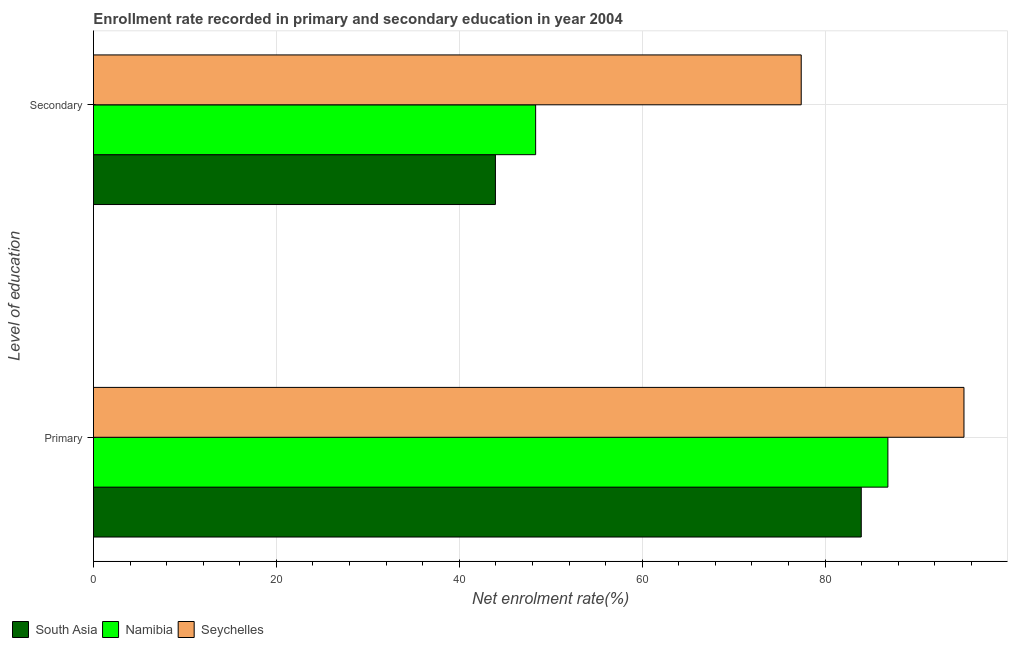How many different coloured bars are there?
Make the answer very short. 3. Are the number of bars on each tick of the Y-axis equal?
Offer a terse response. Yes. What is the label of the 2nd group of bars from the top?
Provide a succinct answer. Primary. What is the enrollment rate in secondary education in Namibia?
Provide a short and direct response. 48.35. Across all countries, what is the maximum enrollment rate in secondary education?
Ensure brevity in your answer.  77.39. Across all countries, what is the minimum enrollment rate in secondary education?
Give a very brief answer. 43.95. In which country was the enrollment rate in primary education maximum?
Give a very brief answer. Seychelles. In which country was the enrollment rate in secondary education minimum?
Provide a succinct answer. South Asia. What is the total enrollment rate in secondary education in the graph?
Provide a succinct answer. 169.69. What is the difference between the enrollment rate in secondary education in Namibia and that in South Asia?
Ensure brevity in your answer.  4.4. What is the difference between the enrollment rate in secondary education in Seychelles and the enrollment rate in primary education in South Asia?
Provide a short and direct response. -6.57. What is the average enrollment rate in primary education per country?
Your response must be concise. 88.67. What is the difference between the enrollment rate in secondary education and enrollment rate in primary education in Seychelles?
Make the answer very short. -17.8. What is the ratio of the enrollment rate in secondary education in Namibia to that in South Asia?
Make the answer very short. 1.1. Is the enrollment rate in primary education in Namibia less than that in Seychelles?
Make the answer very short. Yes. In how many countries, is the enrollment rate in secondary education greater than the average enrollment rate in secondary education taken over all countries?
Your answer should be compact. 1. What does the 3rd bar from the top in Secondary represents?
Give a very brief answer. South Asia. How many bars are there?
Offer a very short reply. 6. Are the values on the major ticks of X-axis written in scientific E-notation?
Make the answer very short. No. How many legend labels are there?
Your answer should be compact. 3. What is the title of the graph?
Your answer should be compact. Enrollment rate recorded in primary and secondary education in year 2004. What is the label or title of the X-axis?
Your response must be concise. Net enrolment rate(%). What is the label or title of the Y-axis?
Provide a succinct answer. Level of education. What is the Net enrolment rate(%) in South Asia in Primary?
Offer a very short reply. 83.96. What is the Net enrolment rate(%) of Namibia in Primary?
Offer a very short reply. 86.87. What is the Net enrolment rate(%) in Seychelles in Primary?
Your response must be concise. 95.19. What is the Net enrolment rate(%) in South Asia in Secondary?
Keep it short and to the point. 43.95. What is the Net enrolment rate(%) in Namibia in Secondary?
Give a very brief answer. 48.35. What is the Net enrolment rate(%) in Seychelles in Secondary?
Keep it short and to the point. 77.39. Across all Level of education, what is the maximum Net enrolment rate(%) in South Asia?
Make the answer very short. 83.96. Across all Level of education, what is the maximum Net enrolment rate(%) in Namibia?
Make the answer very short. 86.87. Across all Level of education, what is the maximum Net enrolment rate(%) of Seychelles?
Make the answer very short. 95.19. Across all Level of education, what is the minimum Net enrolment rate(%) in South Asia?
Your answer should be very brief. 43.95. Across all Level of education, what is the minimum Net enrolment rate(%) in Namibia?
Your answer should be compact. 48.35. Across all Level of education, what is the minimum Net enrolment rate(%) of Seychelles?
Offer a terse response. 77.39. What is the total Net enrolment rate(%) of South Asia in the graph?
Offer a very short reply. 127.91. What is the total Net enrolment rate(%) in Namibia in the graph?
Your answer should be compact. 135.22. What is the total Net enrolment rate(%) in Seychelles in the graph?
Give a very brief answer. 172.58. What is the difference between the Net enrolment rate(%) in South Asia in Primary and that in Secondary?
Offer a terse response. 40.01. What is the difference between the Net enrolment rate(%) of Namibia in Primary and that in Secondary?
Give a very brief answer. 38.52. What is the difference between the Net enrolment rate(%) of Seychelles in Primary and that in Secondary?
Offer a very short reply. 17.8. What is the difference between the Net enrolment rate(%) in South Asia in Primary and the Net enrolment rate(%) in Namibia in Secondary?
Give a very brief answer. 35.61. What is the difference between the Net enrolment rate(%) in South Asia in Primary and the Net enrolment rate(%) in Seychelles in Secondary?
Your answer should be very brief. 6.57. What is the difference between the Net enrolment rate(%) in Namibia in Primary and the Net enrolment rate(%) in Seychelles in Secondary?
Provide a short and direct response. 9.48. What is the average Net enrolment rate(%) in South Asia per Level of education?
Provide a short and direct response. 63.95. What is the average Net enrolment rate(%) of Namibia per Level of education?
Your answer should be very brief. 67.61. What is the average Net enrolment rate(%) in Seychelles per Level of education?
Offer a terse response. 86.29. What is the difference between the Net enrolment rate(%) in South Asia and Net enrolment rate(%) in Namibia in Primary?
Keep it short and to the point. -2.91. What is the difference between the Net enrolment rate(%) in South Asia and Net enrolment rate(%) in Seychelles in Primary?
Give a very brief answer. -11.23. What is the difference between the Net enrolment rate(%) of Namibia and Net enrolment rate(%) of Seychelles in Primary?
Ensure brevity in your answer.  -8.32. What is the difference between the Net enrolment rate(%) of South Asia and Net enrolment rate(%) of Namibia in Secondary?
Offer a terse response. -4.4. What is the difference between the Net enrolment rate(%) in South Asia and Net enrolment rate(%) in Seychelles in Secondary?
Keep it short and to the point. -33.44. What is the difference between the Net enrolment rate(%) of Namibia and Net enrolment rate(%) of Seychelles in Secondary?
Offer a very short reply. -29.04. What is the ratio of the Net enrolment rate(%) of South Asia in Primary to that in Secondary?
Provide a short and direct response. 1.91. What is the ratio of the Net enrolment rate(%) in Namibia in Primary to that in Secondary?
Your answer should be compact. 1.8. What is the ratio of the Net enrolment rate(%) in Seychelles in Primary to that in Secondary?
Your response must be concise. 1.23. What is the difference between the highest and the second highest Net enrolment rate(%) in South Asia?
Keep it short and to the point. 40.01. What is the difference between the highest and the second highest Net enrolment rate(%) in Namibia?
Provide a short and direct response. 38.52. What is the difference between the highest and the second highest Net enrolment rate(%) of Seychelles?
Your answer should be compact. 17.8. What is the difference between the highest and the lowest Net enrolment rate(%) in South Asia?
Offer a terse response. 40.01. What is the difference between the highest and the lowest Net enrolment rate(%) of Namibia?
Make the answer very short. 38.52. What is the difference between the highest and the lowest Net enrolment rate(%) of Seychelles?
Offer a terse response. 17.8. 